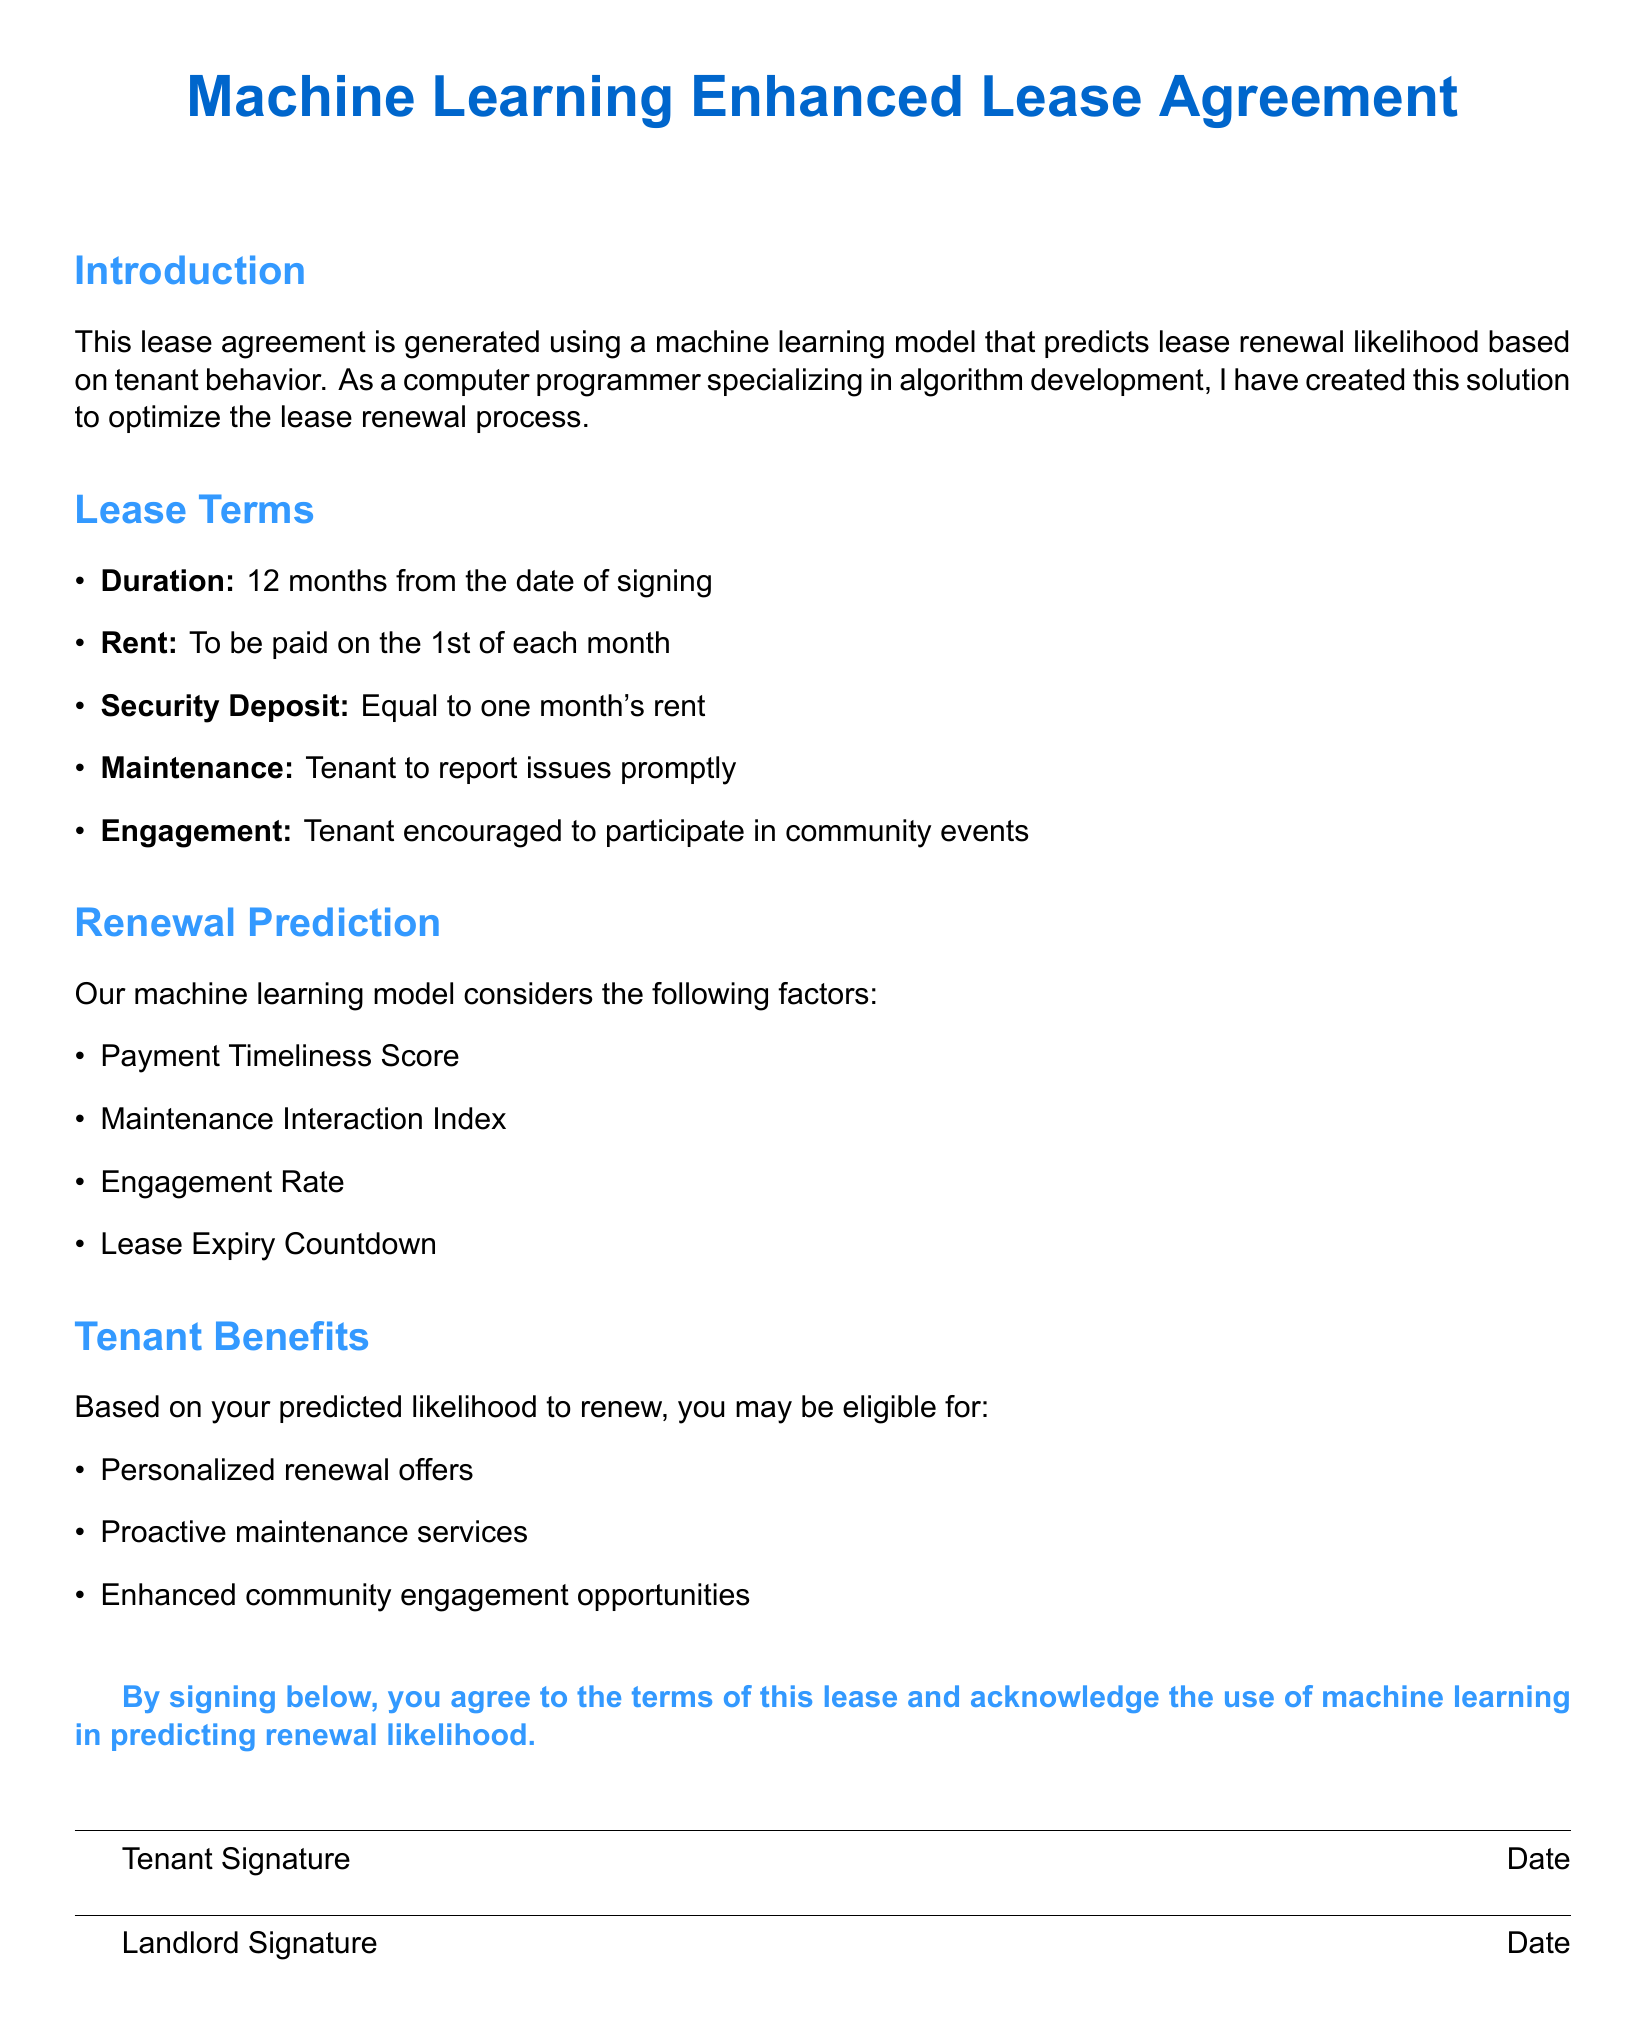What is the duration of the lease? The duration of the lease is specified in the document as 12 months from the date of signing.
Answer: 12 months When is the rent due? The document states that the rent is to be paid on the 1st of each month.
Answer: 1st of each month What is the security deposit amount? According to the lease agreement, the security deposit is equal to one month's rent.
Answer: One month’s rent Name one factor used in the renewal prediction model. The document lists several factors affecting renewal prediction, one of which is the Payment Timeliness Score.
Answer: Payment Timeliness Score What benefit is offered based on the predicted likelihood to renew? The document mentions personalized renewal offers as one of the benefits.
Answer: Personalized renewal offers Who needs to report maintenance issues? The lease agreement states that the tenant is responsible for reporting issues promptly.
Answer: Tenant What does the engagement section encourage? The engagement section encourages tenants to participate in community events.
Answer: Community events What must be signed for the lease agreement to be valid? The lease agreement requires signatures from both the tenant and the landlord to be valid.
Answer: Signatures What color is the title of the document? The title of the document is rendered in a specific color, which is defined in the formatting.
Answer: RGB(0,102,204) 